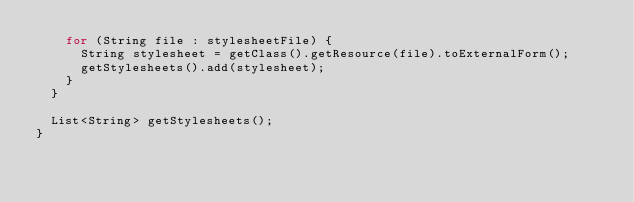Convert code to text. <code><loc_0><loc_0><loc_500><loc_500><_Java_>    for (String file : stylesheetFile) {
      String stylesheet = getClass().getResource(file).toExternalForm();
      getStylesheets().add(stylesheet);
    }
  }

  List<String> getStylesheets();
}
</code> 